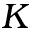Convert formula to latex. <formula><loc_0><loc_0><loc_500><loc_500>K</formula> 